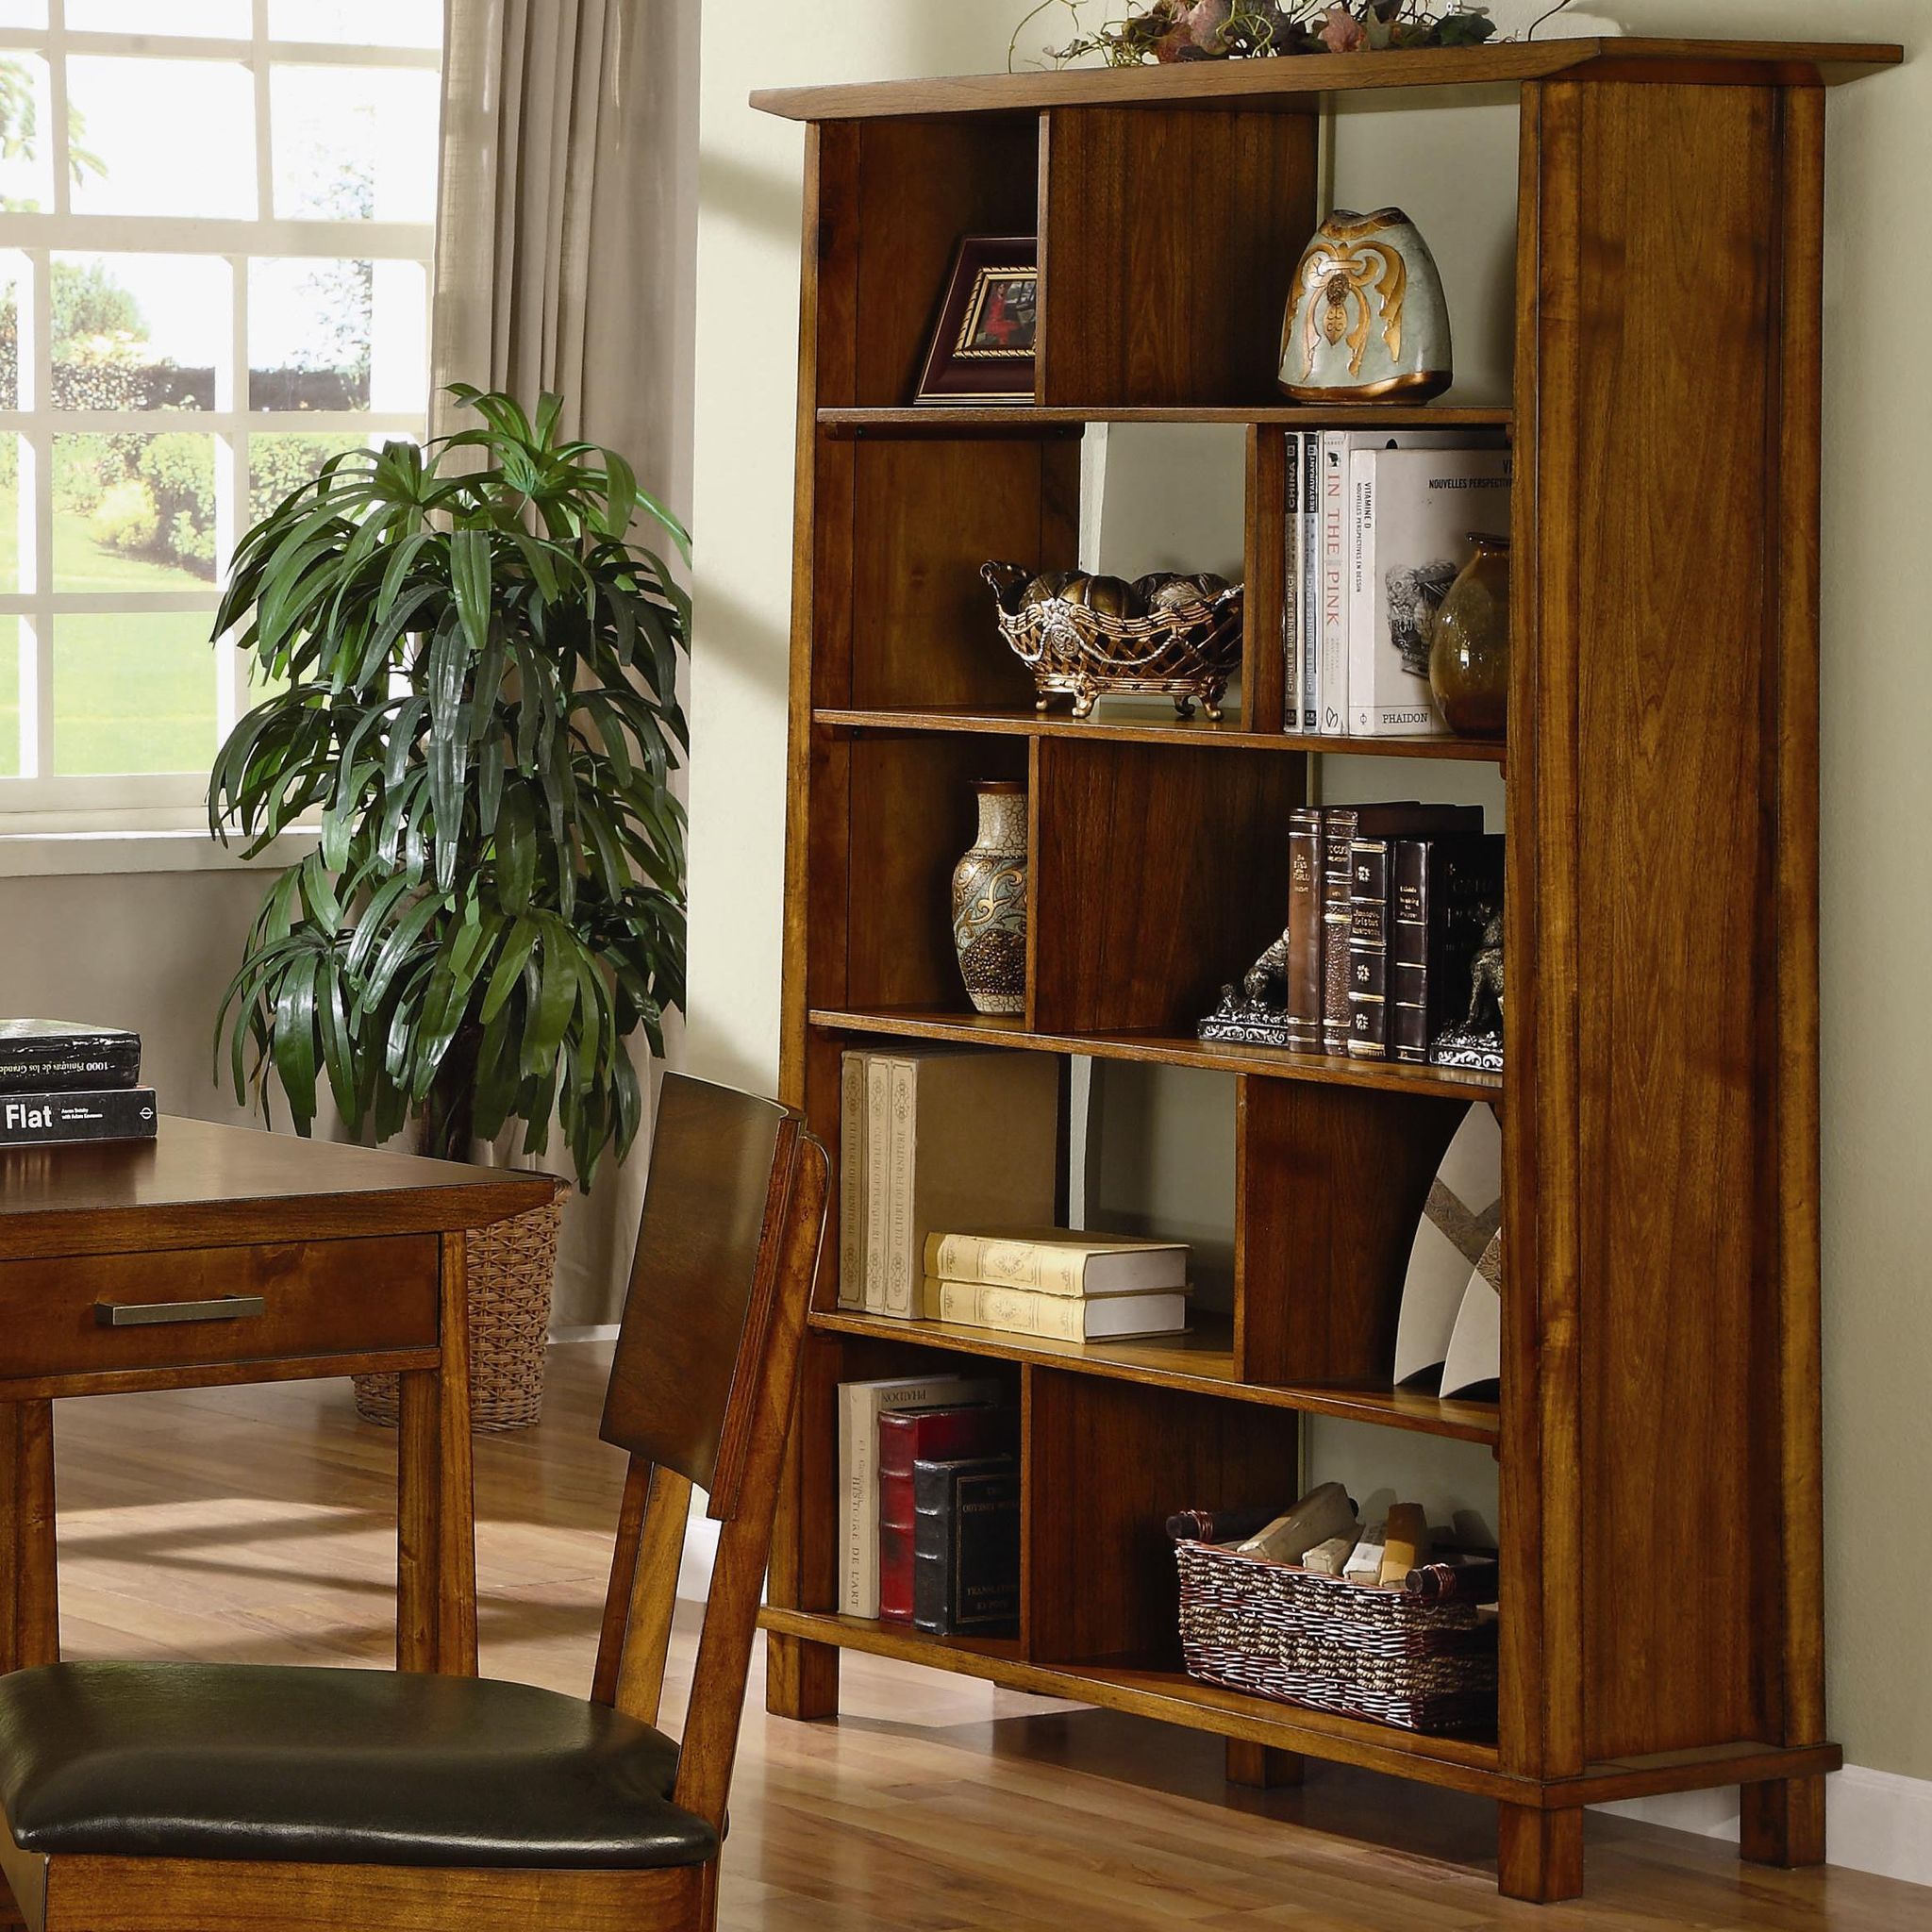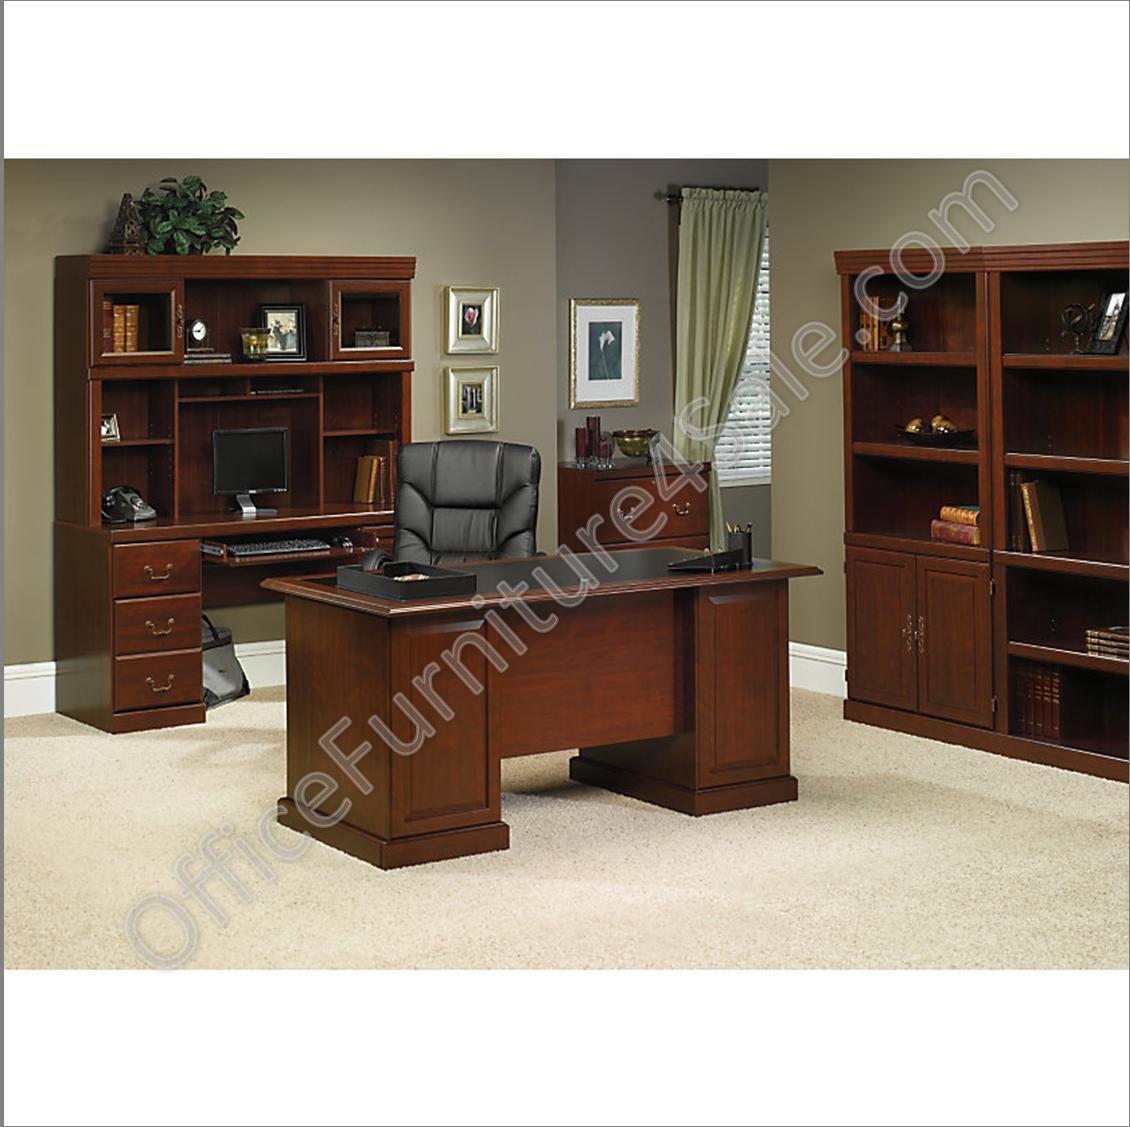The first image is the image on the left, the second image is the image on the right. Evaluate the accuracy of this statement regarding the images: "In at least one image, there is a window with a curtain to the left of a bookcase.". Is it true? Answer yes or no. Yes. The first image is the image on the left, the second image is the image on the right. Examine the images to the left and right. Is the description "There is one skinny bookshelf in the right image and one larger bookshelf in the left image." accurate? Answer yes or no. No. 